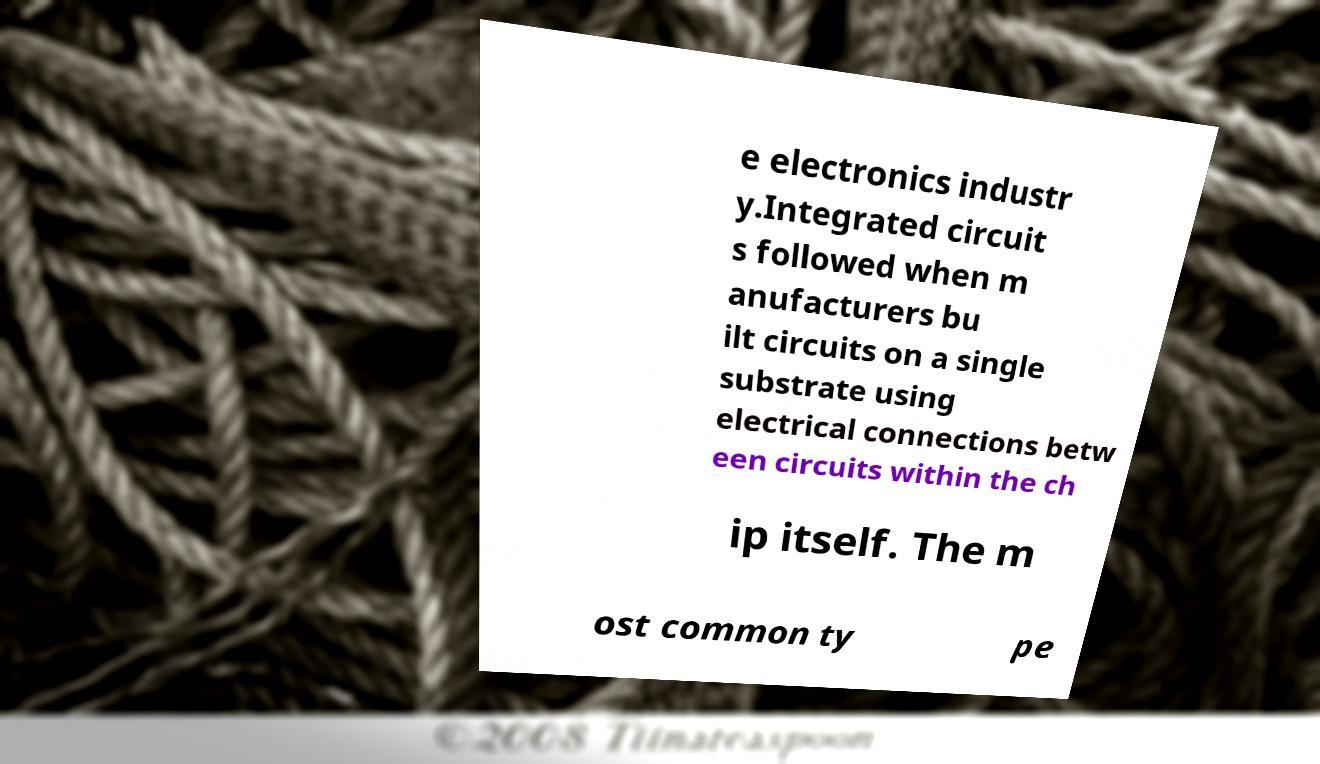I need the written content from this picture converted into text. Can you do that? e electronics industr y.Integrated circuit s followed when m anufacturers bu ilt circuits on a single substrate using electrical connections betw een circuits within the ch ip itself. The m ost common ty pe 